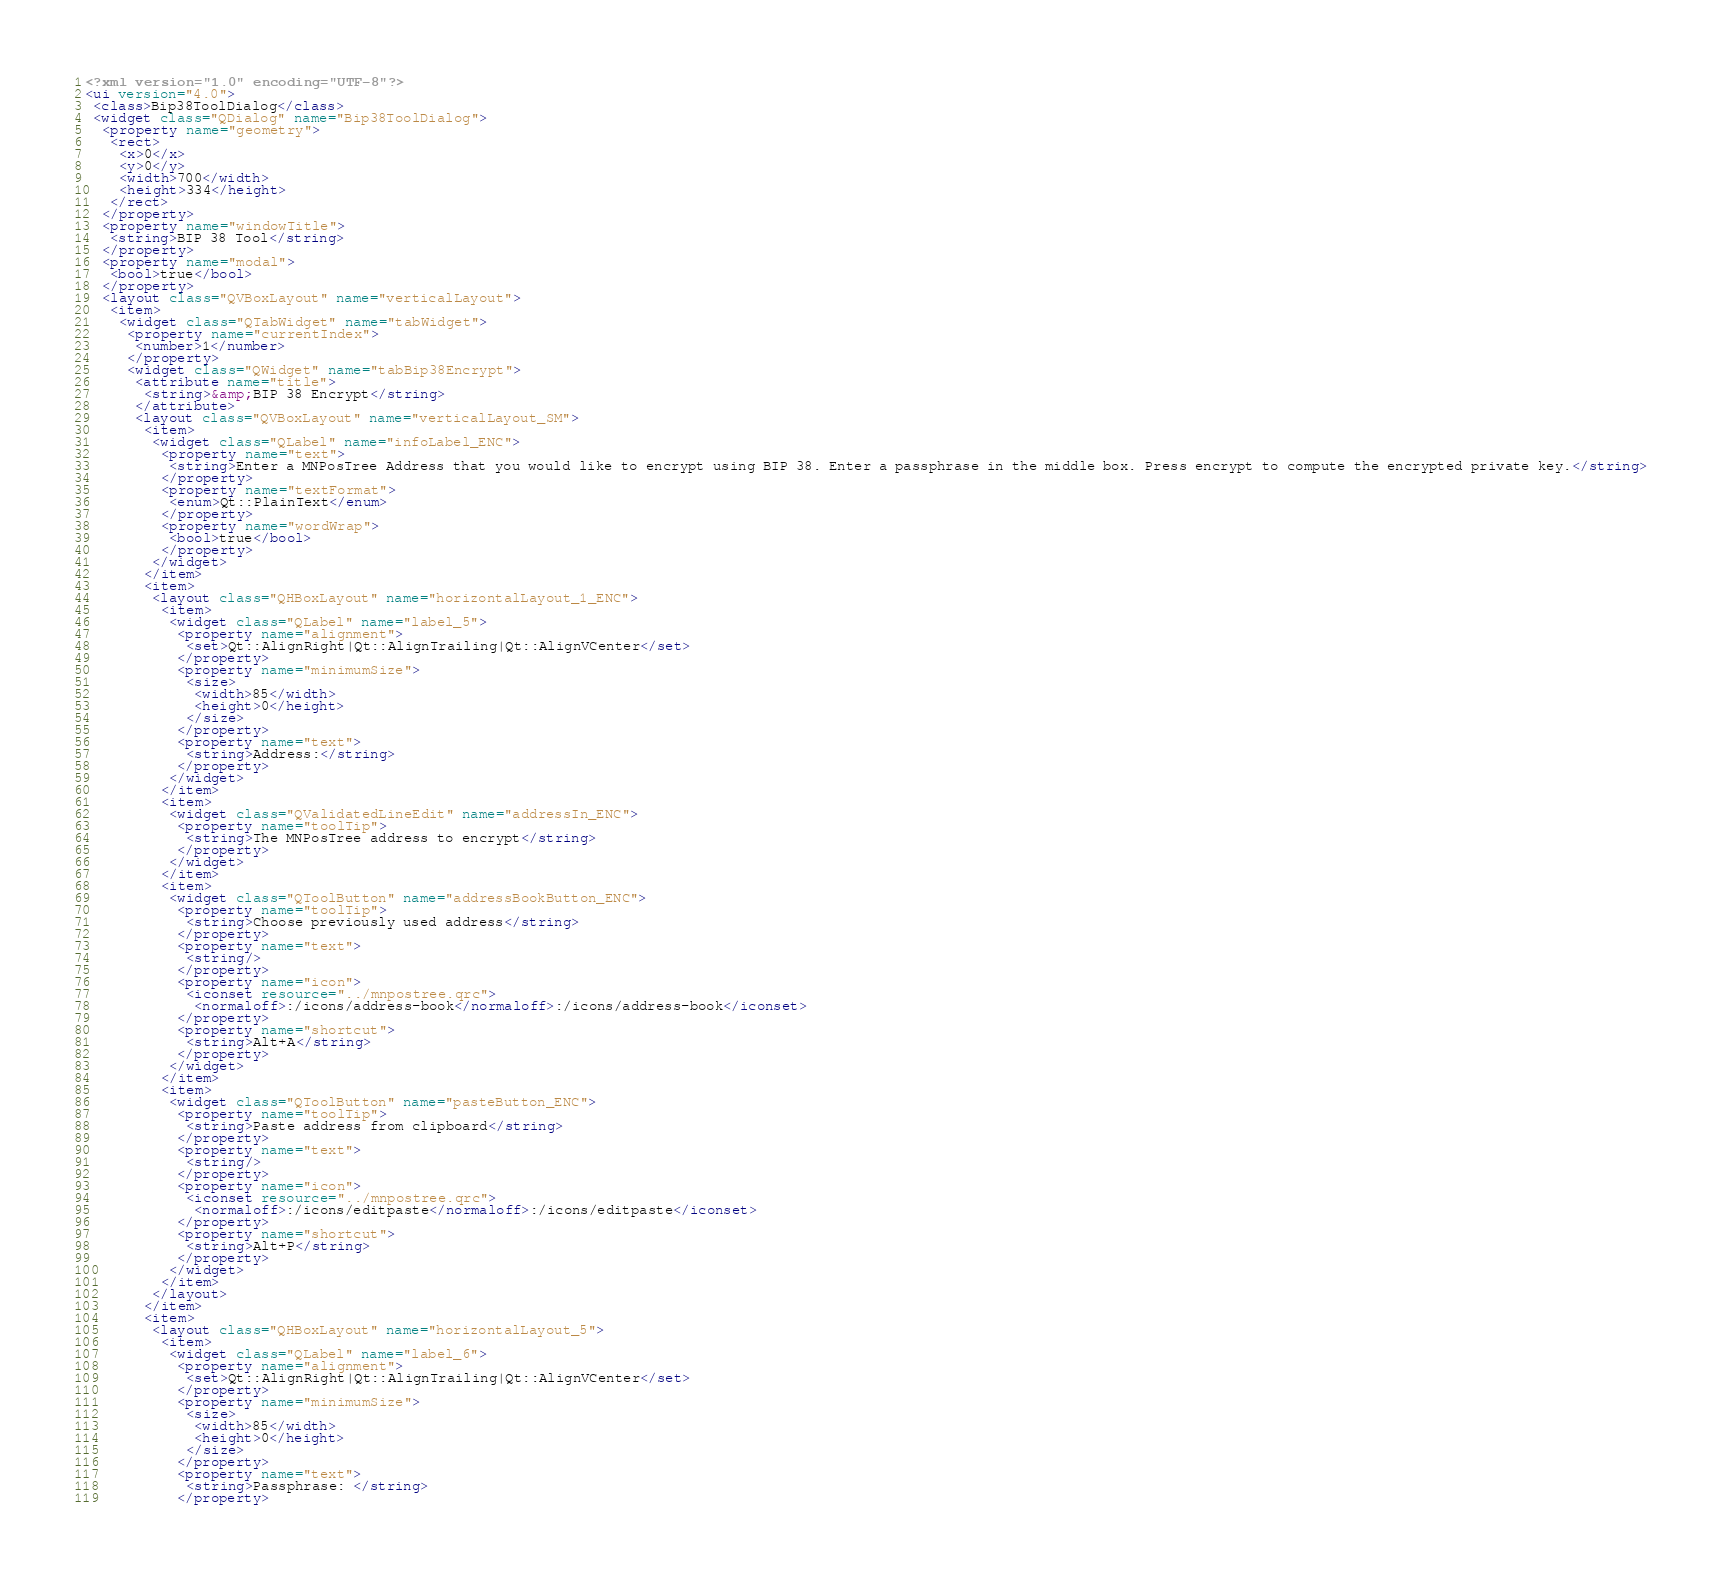Convert code to text. <code><loc_0><loc_0><loc_500><loc_500><_XML_><?xml version="1.0" encoding="UTF-8"?>
<ui version="4.0">
 <class>Bip38ToolDialog</class>
 <widget class="QDialog" name="Bip38ToolDialog">
  <property name="geometry">
   <rect>
    <x>0</x>
    <y>0</y>
    <width>700</width>
    <height>334</height>
   </rect>
  </property>
  <property name="windowTitle">
   <string>BIP 38 Tool</string>
  </property>
  <property name="modal">
   <bool>true</bool>
  </property>
  <layout class="QVBoxLayout" name="verticalLayout">
   <item>
    <widget class="QTabWidget" name="tabWidget">
     <property name="currentIndex">
      <number>1</number>
     </property>
     <widget class="QWidget" name="tabBip38Encrypt">
      <attribute name="title">
       <string>&amp;BIP 38 Encrypt</string>
      </attribute>
      <layout class="QVBoxLayout" name="verticalLayout_SM">
       <item>
        <widget class="QLabel" name="infoLabel_ENC">
         <property name="text">
          <string>Enter a MNPosTree Address that you would like to encrypt using BIP 38. Enter a passphrase in the middle box. Press encrypt to compute the encrypted private key.</string>
         </property>
         <property name="textFormat">
          <enum>Qt::PlainText</enum>
         </property>
         <property name="wordWrap">
          <bool>true</bool>
         </property>
        </widget>
       </item>
       <item>
        <layout class="QHBoxLayout" name="horizontalLayout_1_ENC">
         <item>
          <widget class="QLabel" name="label_5">
           <property name="alignment">
            <set>Qt::AlignRight|Qt::AlignTrailing|Qt::AlignVCenter</set>
           </property>
           <property name="minimumSize">
            <size>
             <width>85</width>
             <height>0</height>
            </size>
           </property>
           <property name="text">
            <string>Address:</string>
           </property>
          </widget>
         </item>
         <item>
          <widget class="QValidatedLineEdit" name="addressIn_ENC">
           <property name="toolTip">
            <string>The MNPosTree address to encrypt</string>
           </property>
          </widget>
         </item>
         <item>
          <widget class="QToolButton" name="addressBookButton_ENC">
           <property name="toolTip">
            <string>Choose previously used address</string>
           </property>
           <property name="text">
            <string/>
           </property>
           <property name="icon">
            <iconset resource="../mnpostree.qrc">
             <normaloff>:/icons/address-book</normaloff>:/icons/address-book</iconset>
           </property>
           <property name="shortcut">
            <string>Alt+A</string>
           </property>
          </widget>
         </item>
         <item>
          <widget class="QToolButton" name="pasteButton_ENC">
           <property name="toolTip">
            <string>Paste address from clipboard</string>
           </property>
           <property name="text">
            <string/>
           </property>
           <property name="icon">
            <iconset resource="../mnpostree.qrc">
             <normaloff>:/icons/editpaste</normaloff>:/icons/editpaste</iconset>
           </property>
           <property name="shortcut">
            <string>Alt+P</string>
           </property>
          </widget>
         </item>
        </layout>
       </item>
       <item>
        <layout class="QHBoxLayout" name="horizontalLayout_5">
         <item>
          <widget class="QLabel" name="label_6">
           <property name="alignment">
            <set>Qt::AlignRight|Qt::AlignTrailing|Qt::AlignVCenter</set>
           </property>
           <property name="minimumSize">
            <size>
             <width>85</width>
             <height>0</height>
            </size>
           </property>
           <property name="text">
            <string>Passphrase: </string>
           </property></code> 